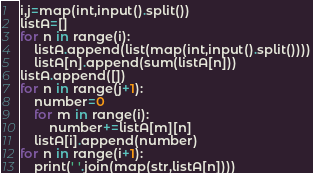Convert code to text. <code><loc_0><loc_0><loc_500><loc_500><_Python_>i,j=map(int,input().split())
listA=[]
for n in range(i):
    listA.append(list(map(int,input().split())))
    listA[n].append(sum(listA[n]))
listA.append([])
for n in range(j+1):
    number=0
    for m in range(i):
        number+=listA[m][n]
    listA[i].append(number)
for n in range(i+1):
    print(' '.join(map(str,listA[n])))

</code> 